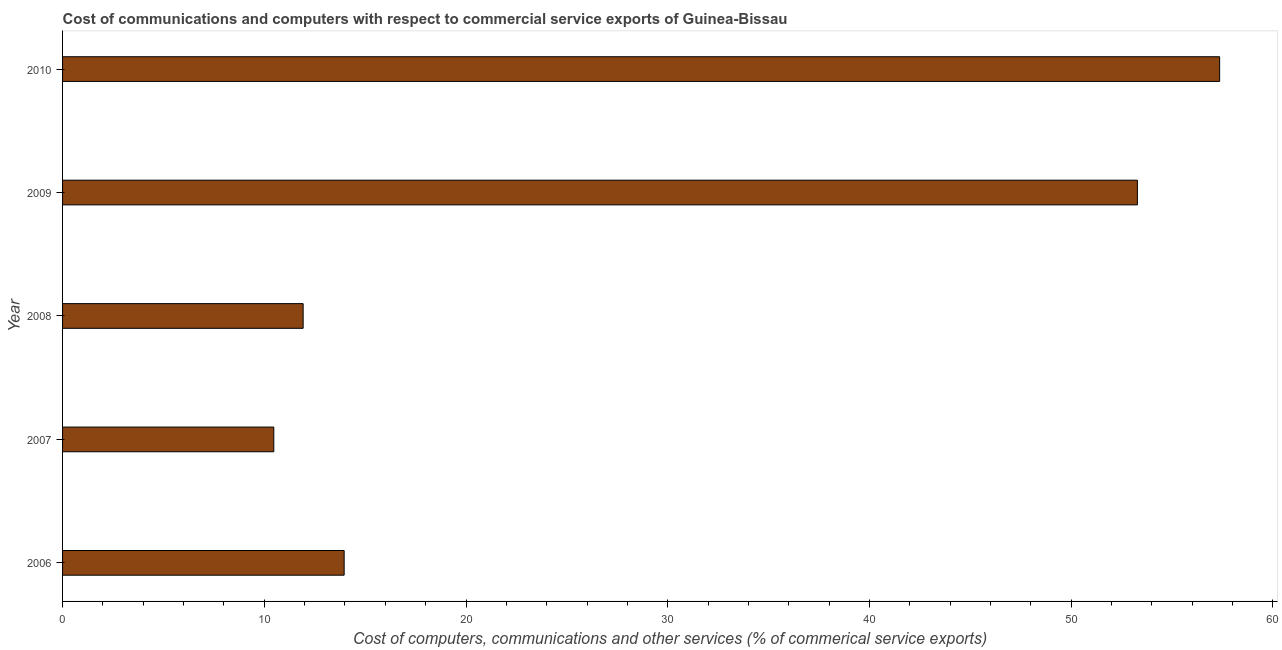Does the graph contain any zero values?
Offer a terse response. No. Does the graph contain grids?
Provide a succinct answer. No. What is the title of the graph?
Your answer should be compact. Cost of communications and computers with respect to commercial service exports of Guinea-Bissau. What is the label or title of the X-axis?
Provide a short and direct response. Cost of computers, communications and other services (% of commerical service exports). What is the label or title of the Y-axis?
Offer a terse response. Year. What is the  computer and other services in 2008?
Give a very brief answer. 11.93. Across all years, what is the maximum cost of communications?
Your response must be concise. 57.36. Across all years, what is the minimum cost of communications?
Your response must be concise. 10.47. What is the sum of the  computer and other services?
Give a very brief answer. 146.99. What is the difference between the  computer and other services in 2006 and 2010?
Make the answer very short. -43.4. What is the average cost of communications per year?
Offer a very short reply. 29.4. What is the median cost of communications?
Give a very brief answer. 13.96. In how many years, is the cost of communications greater than 58 %?
Your answer should be very brief. 0. Do a majority of the years between 2006 and 2010 (inclusive) have  computer and other services greater than 42 %?
Your answer should be compact. No. What is the ratio of the  computer and other services in 2008 to that in 2009?
Your answer should be compact. 0.22. Is the cost of communications in 2006 less than that in 2009?
Your answer should be compact. Yes. Is the difference between the cost of communications in 2008 and 2010 greater than the difference between any two years?
Your answer should be compact. No. What is the difference between the highest and the second highest  computer and other services?
Ensure brevity in your answer.  4.08. Is the sum of the  computer and other services in 2006 and 2007 greater than the maximum  computer and other services across all years?
Provide a short and direct response. No. What is the difference between the highest and the lowest  computer and other services?
Your response must be concise. 46.89. How many bars are there?
Your response must be concise. 5. How many years are there in the graph?
Offer a very short reply. 5. What is the difference between two consecutive major ticks on the X-axis?
Offer a very short reply. 10. What is the Cost of computers, communications and other services (% of commerical service exports) of 2006?
Provide a succinct answer. 13.96. What is the Cost of computers, communications and other services (% of commerical service exports) of 2007?
Ensure brevity in your answer.  10.47. What is the Cost of computers, communications and other services (% of commerical service exports) in 2008?
Your answer should be very brief. 11.93. What is the Cost of computers, communications and other services (% of commerical service exports) of 2009?
Your answer should be compact. 53.28. What is the Cost of computers, communications and other services (% of commerical service exports) in 2010?
Provide a succinct answer. 57.36. What is the difference between the Cost of computers, communications and other services (% of commerical service exports) in 2006 and 2007?
Provide a succinct answer. 3.49. What is the difference between the Cost of computers, communications and other services (% of commerical service exports) in 2006 and 2008?
Your response must be concise. 2.03. What is the difference between the Cost of computers, communications and other services (% of commerical service exports) in 2006 and 2009?
Make the answer very short. -39.32. What is the difference between the Cost of computers, communications and other services (% of commerical service exports) in 2006 and 2010?
Your answer should be compact. -43.4. What is the difference between the Cost of computers, communications and other services (% of commerical service exports) in 2007 and 2008?
Offer a very short reply. -1.45. What is the difference between the Cost of computers, communications and other services (% of commerical service exports) in 2007 and 2009?
Provide a succinct answer. -42.81. What is the difference between the Cost of computers, communications and other services (% of commerical service exports) in 2007 and 2010?
Ensure brevity in your answer.  -46.89. What is the difference between the Cost of computers, communications and other services (% of commerical service exports) in 2008 and 2009?
Provide a succinct answer. -41.36. What is the difference between the Cost of computers, communications and other services (% of commerical service exports) in 2008 and 2010?
Keep it short and to the point. -45.43. What is the difference between the Cost of computers, communications and other services (% of commerical service exports) in 2009 and 2010?
Offer a terse response. -4.08. What is the ratio of the Cost of computers, communications and other services (% of commerical service exports) in 2006 to that in 2007?
Keep it short and to the point. 1.33. What is the ratio of the Cost of computers, communications and other services (% of commerical service exports) in 2006 to that in 2008?
Give a very brief answer. 1.17. What is the ratio of the Cost of computers, communications and other services (% of commerical service exports) in 2006 to that in 2009?
Provide a succinct answer. 0.26. What is the ratio of the Cost of computers, communications and other services (% of commerical service exports) in 2006 to that in 2010?
Offer a very short reply. 0.24. What is the ratio of the Cost of computers, communications and other services (% of commerical service exports) in 2007 to that in 2008?
Offer a very short reply. 0.88. What is the ratio of the Cost of computers, communications and other services (% of commerical service exports) in 2007 to that in 2009?
Give a very brief answer. 0.2. What is the ratio of the Cost of computers, communications and other services (% of commerical service exports) in 2007 to that in 2010?
Your answer should be compact. 0.18. What is the ratio of the Cost of computers, communications and other services (% of commerical service exports) in 2008 to that in 2009?
Your answer should be compact. 0.22. What is the ratio of the Cost of computers, communications and other services (% of commerical service exports) in 2008 to that in 2010?
Offer a very short reply. 0.21. What is the ratio of the Cost of computers, communications and other services (% of commerical service exports) in 2009 to that in 2010?
Give a very brief answer. 0.93. 